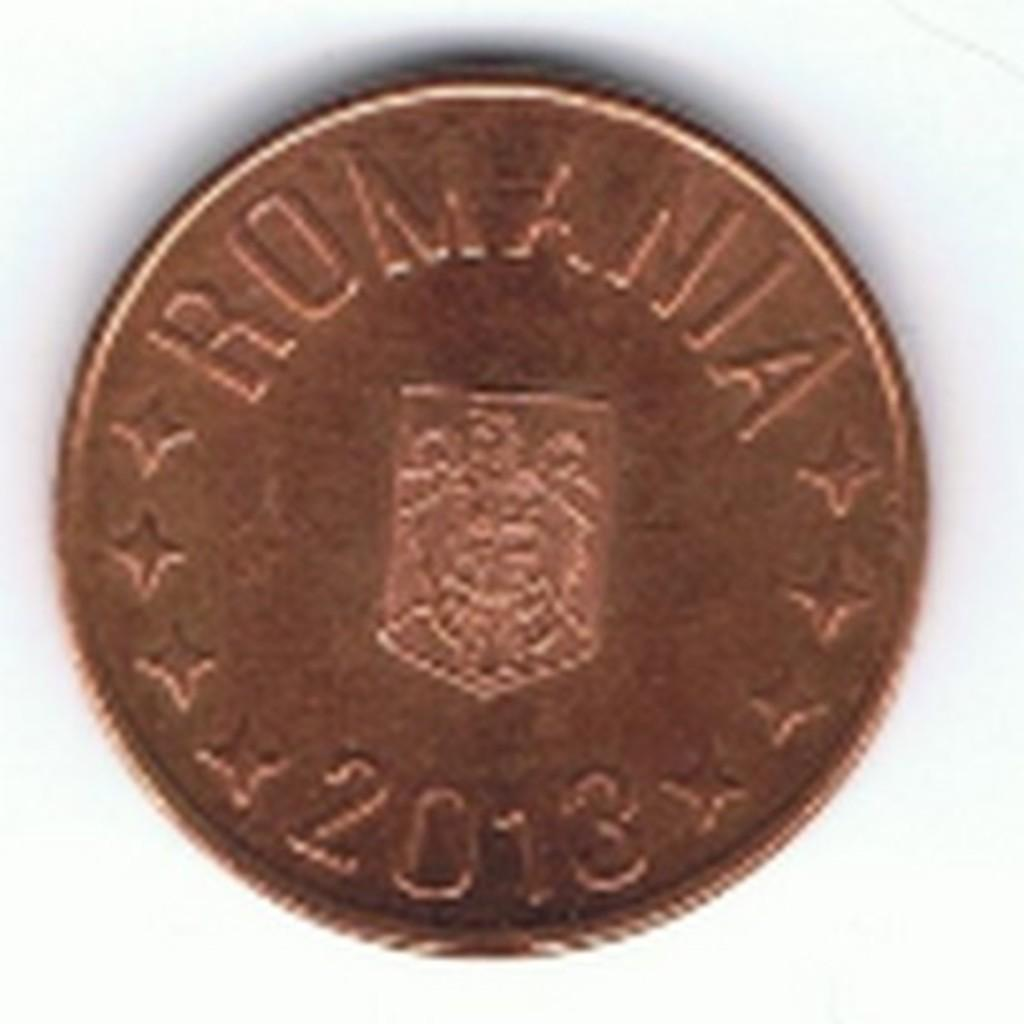<image>
Write a terse but informative summary of the picture. A slightly blurred picture of a 2013 Romanian coin 